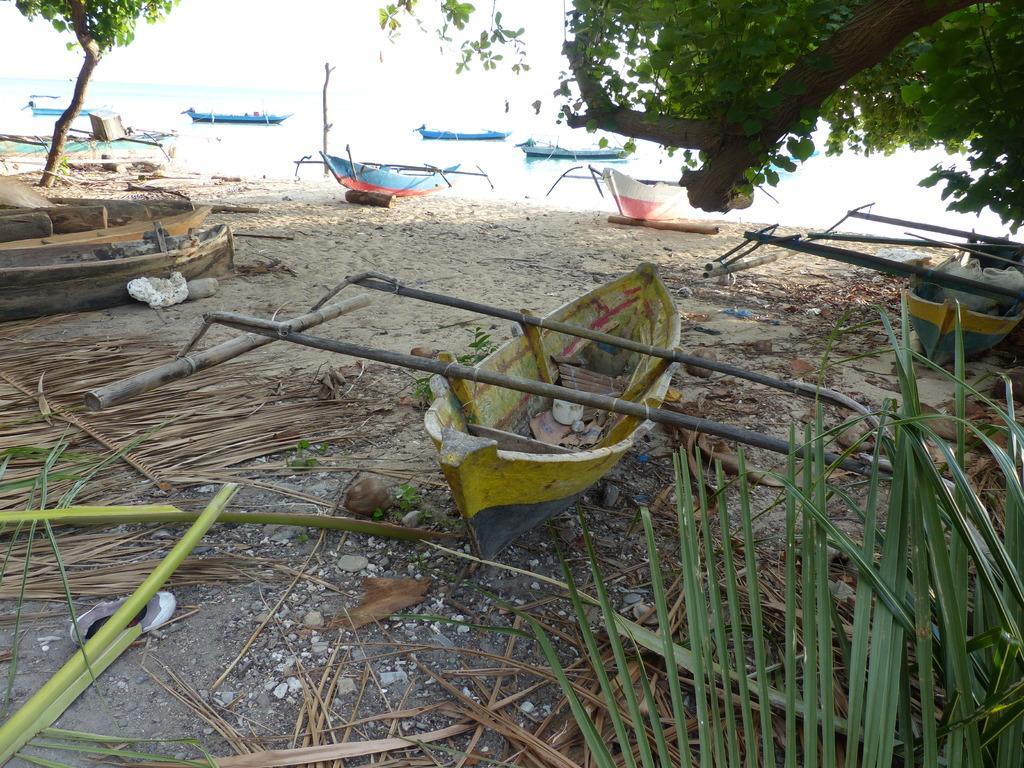In one or two sentences, can you explain what this image depicts? In the picture we can see a sand surface with some dried plants, leaves, boats and some stones and behind the sand surface, we can see water and in it we can see some boats. 